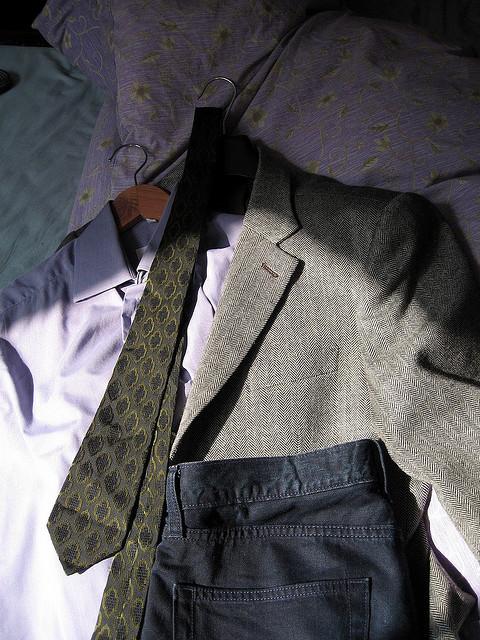What kind of pants are laying out?
Quick response, please. Jeans. What are the clothes laying on?
Give a very brief answer. Bed. What pattern is on the tie?
Write a very short answer. Diamonds. 